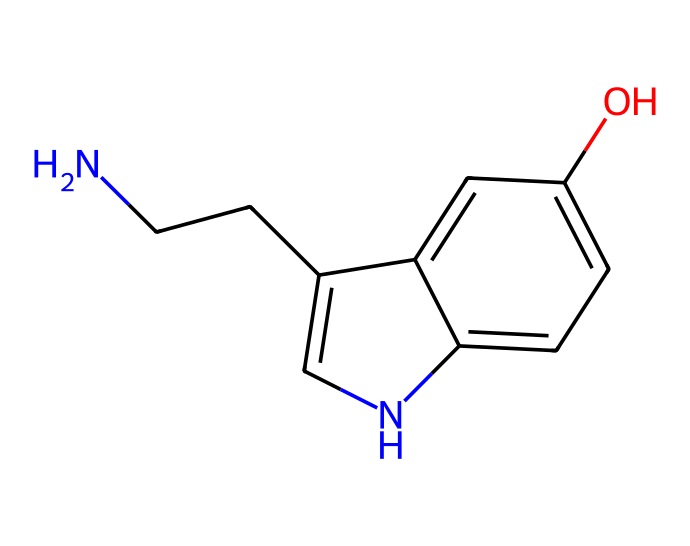What is the molecular formula of this compound? By analyzing the SMILES representation of the chemical, we can deduce the number of each type of atom present. Counting the atoms: there are 10 carbon (C) atoms, 12 hydrogen (H) atoms, 1 nitrogen (N) atom, and 1 oxygen (O) atom. Thus, the molecular formula is C10H12N2O.
Answer: C10H12N2O How many nitrogen atoms are in the structure? The SMILES notation indicates one nitrogen symbol (N), which signifies that there is one nitrogen atom in the structure.
Answer: 1 What type of bonding is primarily present in this compound? The presence of single and some double bonds in the SMILES notation suggests covalent bonding as the primary type present in this compound. This is common in organic molecules.
Answer: covalent Is this compound a neurotransmitter? Yes, serotonin, which this compound represents, is a neurotransmitter known for its role in modulating mood and happiness.
Answer: yes Explain the significance of the hydroxyl group in this compound. The hydroxyl group (–OH) is a functional group present in the structure. It increases the molecule's polarity, enhancing its solubility in water, which is crucial for serotonin's function as a neurotransmitter in the aqueous environment of neurons.
Answer: increases solubility What does the presence of a benzene ring indicate about this compound? The presence of a benzene ring indicates that the compound exhibits aromatic properties, contributing to its stability and influence on its biological function as a neurotransmitter.
Answer: aromatic stability How does the structure relate to serotonin's function in happiness? The complex structure, including the aromatic ring and the hydroxyl group, contributes to interactions with receptors in the brain, influencing mood regulation and feelings of happiness; these structural features are essential for its function as a neurotransmitter.
Answer: receptor interaction 